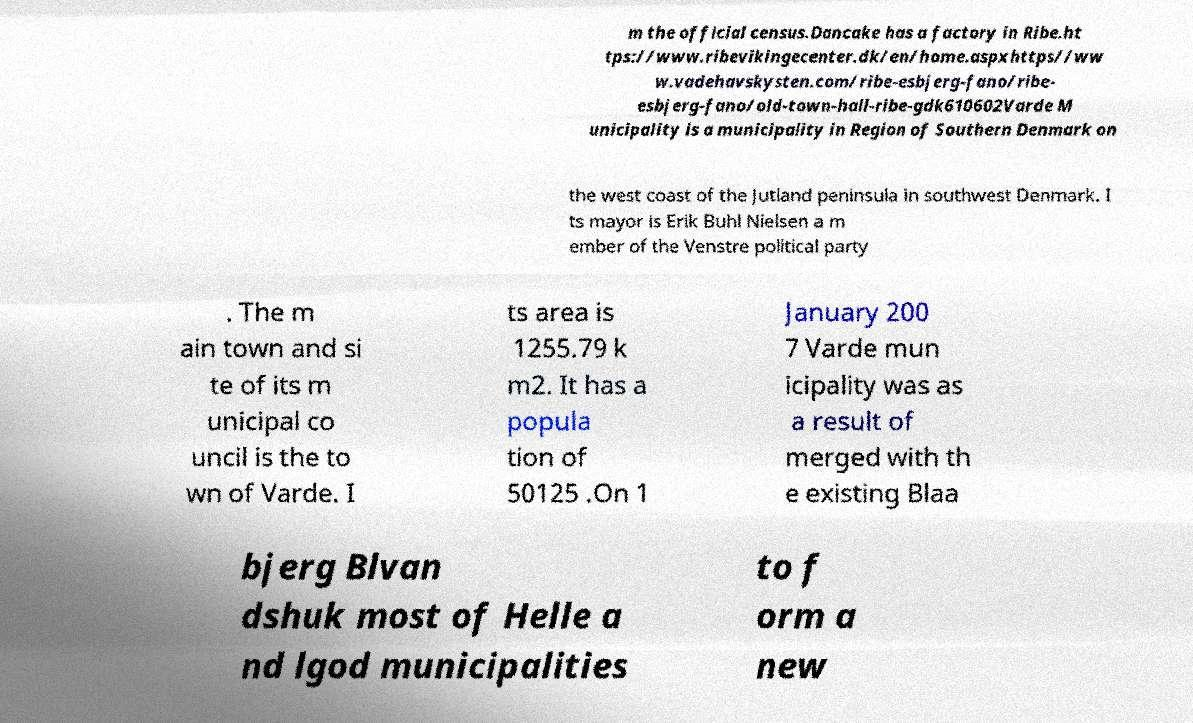Can you accurately transcribe the text from the provided image for me? m the official census.Dancake has a factory in Ribe.ht tps://www.ribevikingecenter.dk/en/home.aspxhttps//ww w.vadehavskysten.com/ribe-esbjerg-fano/ribe- esbjerg-fano/old-town-hall-ribe-gdk610602Varde M unicipality is a municipality in Region of Southern Denmark on the west coast of the Jutland peninsula in southwest Denmark. I ts mayor is Erik Buhl Nielsen a m ember of the Venstre political party . The m ain town and si te of its m unicipal co uncil is the to wn of Varde. I ts area is 1255.79 k m2. It has a popula tion of 50125 .On 1 January 200 7 Varde mun icipality was as a result of merged with th e existing Blaa bjerg Blvan dshuk most of Helle a nd lgod municipalities to f orm a new 